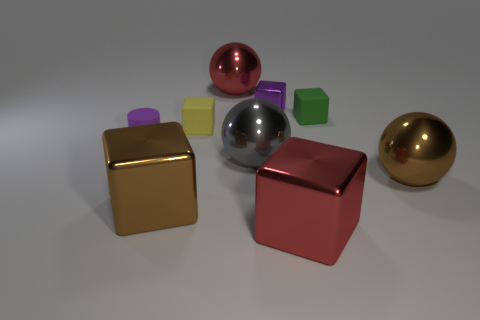How big is the gray shiny sphere?
Your response must be concise. Large. There is a small matte thing that is the same color as the tiny metal block; what is its shape?
Your answer should be compact. Cylinder. How many spheres are either purple shiny objects or gray objects?
Your answer should be compact. 1. Is the number of rubber objects to the right of the small green thing the same as the number of big gray metal balls to the right of the tiny purple matte cylinder?
Make the answer very short. No. The brown thing that is the same shape as the yellow object is what size?
Make the answer very short. Large. There is a metal thing that is both left of the big gray shiny thing and behind the green block; what size is it?
Ensure brevity in your answer.  Large. Are there any matte things behind the yellow matte block?
Offer a very short reply. Yes. How many things are big metallic objects that are in front of the purple cylinder or tiny rubber things?
Keep it short and to the point. 7. There is a red object that is behind the brown ball; what number of tiny purple metallic cubes are behind it?
Ensure brevity in your answer.  0. Is the number of tiny purple metal blocks behind the big red metal sphere less than the number of purple shiny blocks that are on the right side of the small yellow rubber cube?
Provide a succinct answer. Yes. 